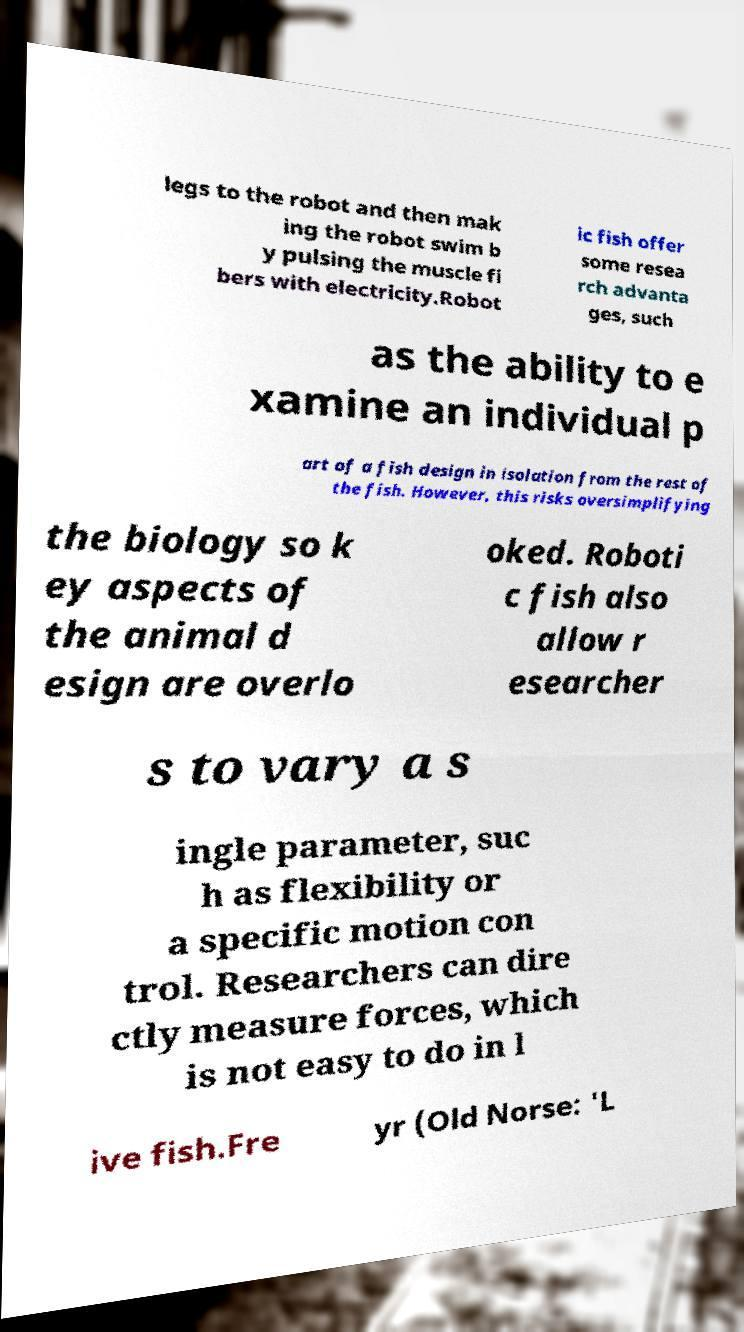Please read and relay the text visible in this image. What does it say? legs to the robot and then mak ing the robot swim b y pulsing the muscle fi bers with electricity.Robot ic fish offer some resea rch advanta ges, such as the ability to e xamine an individual p art of a fish design in isolation from the rest of the fish. However, this risks oversimplifying the biology so k ey aspects of the animal d esign are overlo oked. Roboti c fish also allow r esearcher s to vary a s ingle parameter, suc h as flexibility or a specific motion con trol. Researchers can dire ctly measure forces, which is not easy to do in l ive fish.Fre yr (Old Norse: 'L 